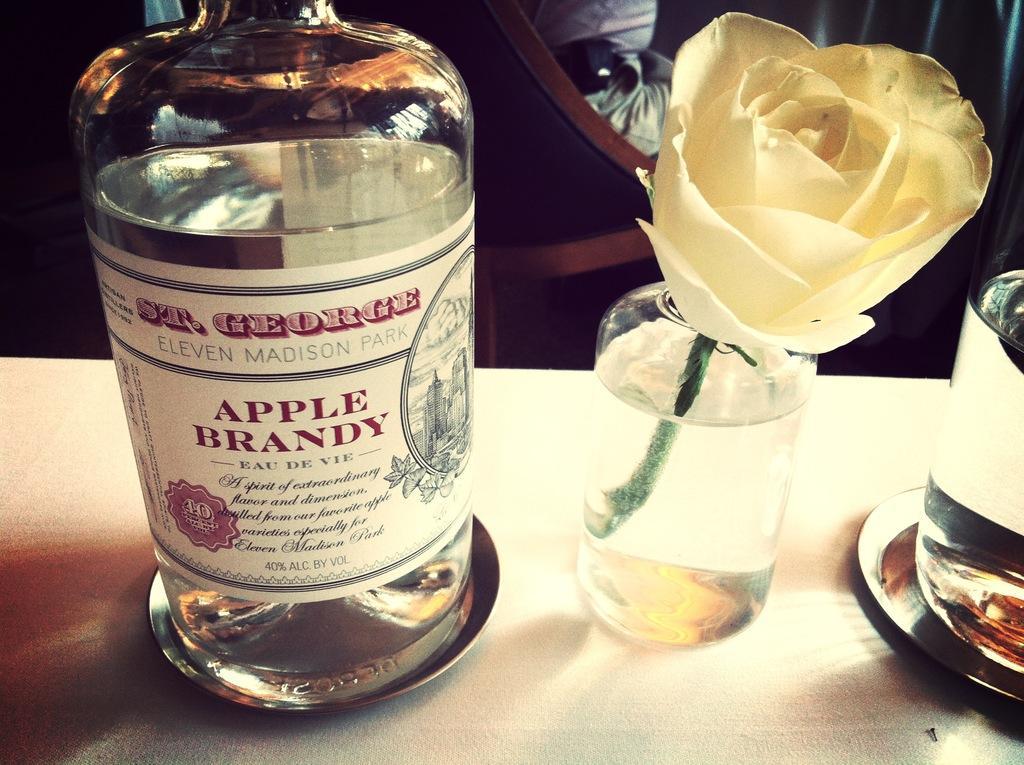In one or two sentences, can you explain what this image depicts? In this picture there as a wine bottle kept on a table and a glass with a flower and it is also glass and a plate and the table and in the back from that some person sitting on the chair 